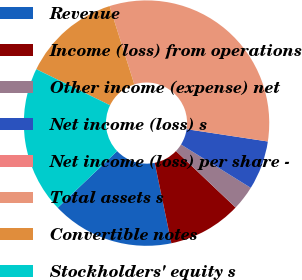Convert chart to OTSL. <chart><loc_0><loc_0><loc_500><loc_500><pie_chart><fcel>Revenue<fcel>Income (loss) from operations<fcel>Other income (expense) net<fcel>Net income (loss) s<fcel>Net income (loss) per share -<fcel>Total assets s<fcel>Convertible notes<fcel>Stockholders' equity s<nl><fcel>16.13%<fcel>9.68%<fcel>3.23%<fcel>6.45%<fcel>0.0%<fcel>32.26%<fcel>12.9%<fcel>19.35%<nl></chart> 